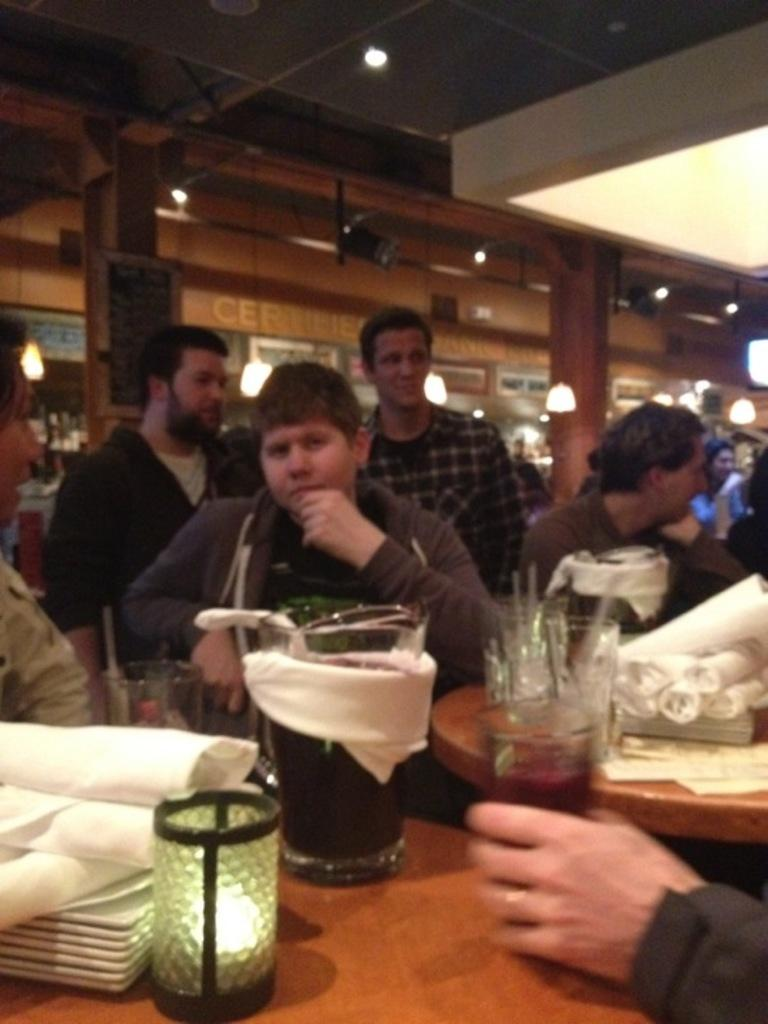What items can be seen on the tables in the image? There are clothes, glasses, and plates on the tables. Are there any other items on the tables besides clothes, glasses, and plates? Yes, there are other unspecified things on the tables. What can be observed in the background of the image? There are people, lights, and a board in the background. How many leaves are on the table in the image? There are no leaves present on the tables in the image. What type of step is visible in the image? There is no step visible in the image. 